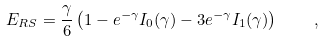Convert formula to latex. <formula><loc_0><loc_0><loc_500><loc_500>E _ { R S } = \frac { \gamma } { 6 } \left ( 1 - e ^ { - \gamma } I _ { 0 } ( \gamma ) - 3 e ^ { - \gamma } I _ { 1 } ( \gamma ) \right ) \quad ,</formula> 